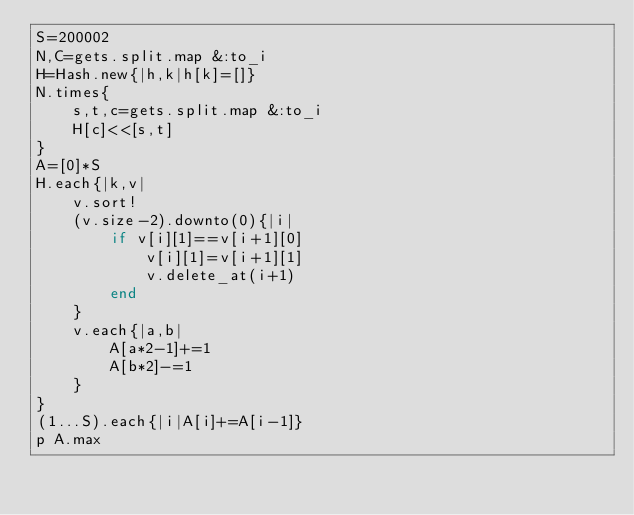Convert code to text. <code><loc_0><loc_0><loc_500><loc_500><_Ruby_>S=200002
N,C=gets.split.map &:to_i
H=Hash.new{|h,k|h[k]=[]}
N.times{
	s,t,c=gets.split.map &:to_i
	H[c]<<[s,t]
}
A=[0]*S
H.each{|k,v|
	v.sort!
	(v.size-2).downto(0){|i|
		if v[i][1]==v[i+1][0]
			v[i][1]=v[i+1][1]
			v.delete_at(i+1)
		end
	}
	v.each{|a,b|
		A[a*2-1]+=1
		A[b*2]-=1
	}
}
(1...S).each{|i|A[i]+=A[i-1]}
p A.max</code> 